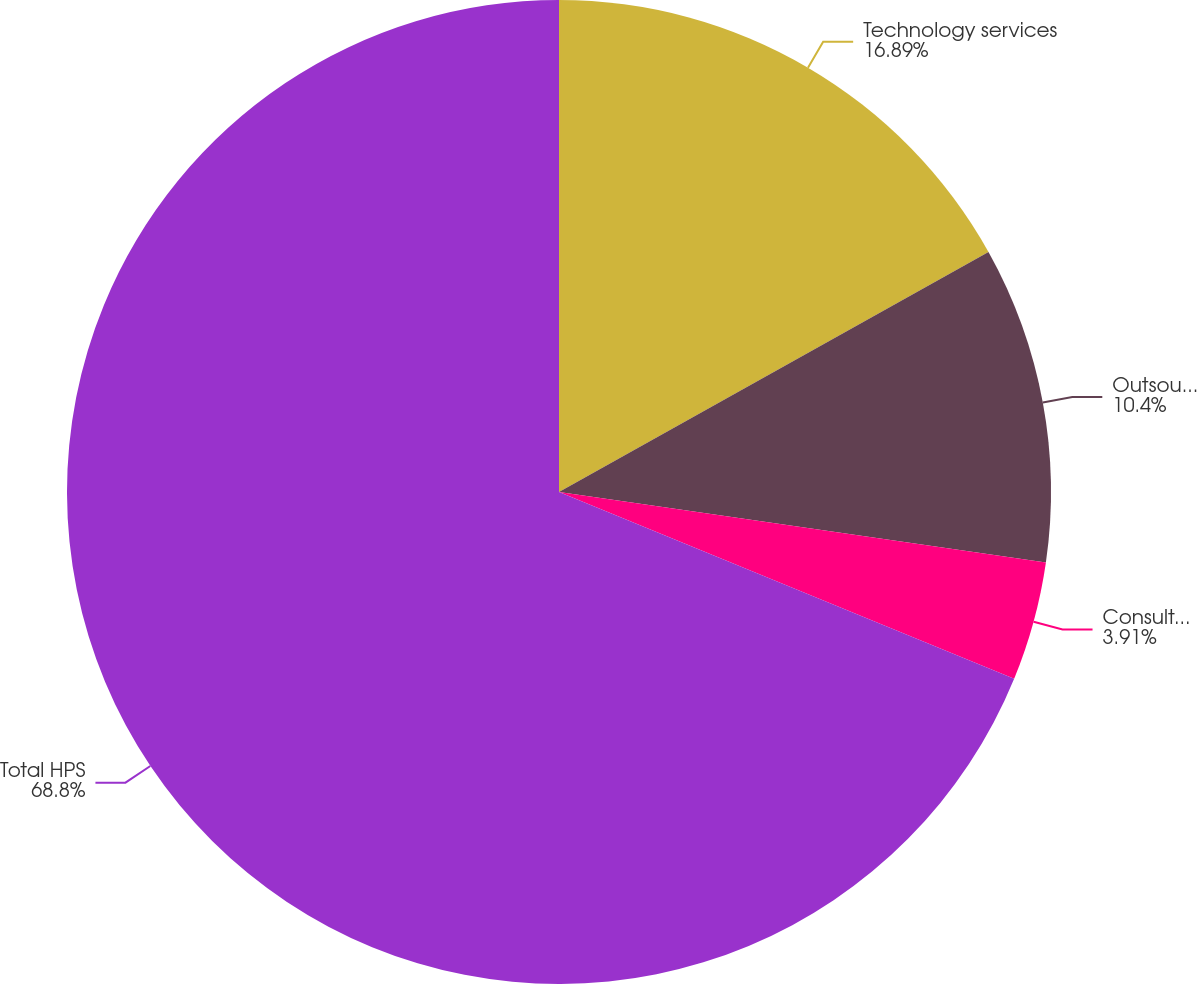Convert chart. <chart><loc_0><loc_0><loc_500><loc_500><pie_chart><fcel>Technology services<fcel>Outsourcing services<fcel>Consulting and integration<fcel>Total HPS<nl><fcel>16.89%<fcel>10.4%<fcel>3.91%<fcel>68.8%<nl></chart> 